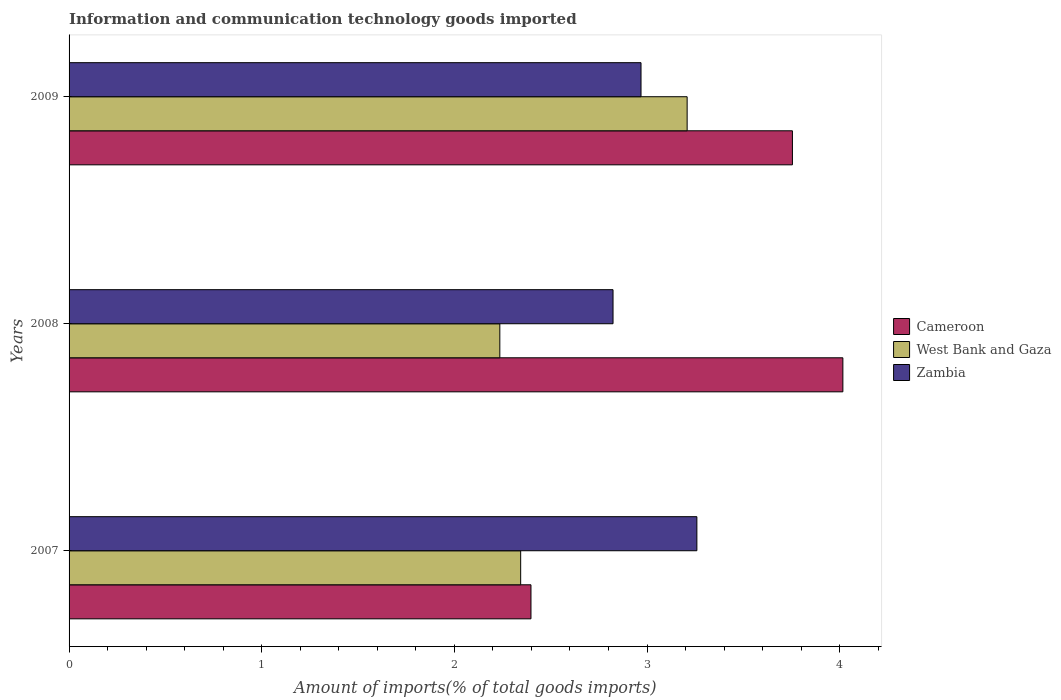What is the label of the 1st group of bars from the top?
Offer a terse response. 2009. What is the amount of goods imported in Cameroon in 2008?
Offer a very short reply. 4.02. Across all years, what is the maximum amount of goods imported in Zambia?
Provide a succinct answer. 3.26. Across all years, what is the minimum amount of goods imported in Cameroon?
Provide a succinct answer. 2.4. In which year was the amount of goods imported in West Bank and Gaza maximum?
Ensure brevity in your answer.  2009. In which year was the amount of goods imported in Cameroon minimum?
Offer a terse response. 2007. What is the total amount of goods imported in Cameroon in the graph?
Make the answer very short. 10.17. What is the difference between the amount of goods imported in Cameroon in 2007 and that in 2009?
Your answer should be very brief. -1.36. What is the difference between the amount of goods imported in Zambia in 2009 and the amount of goods imported in West Bank and Gaza in 2007?
Provide a short and direct response. 0.62. What is the average amount of goods imported in Cameroon per year?
Give a very brief answer. 3.39. In the year 2007, what is the difference between the amount of goods imported in Zambia and amount of goods imported in Cameroon?
Ensure brevity in your answer.  0.86. In how many years, is the amount of goods imported in West Bank and Gaza greater than 0.2 %?
Keep it short and to the point. 3. What is the ratio of the amount of goods imported in Zambia in 2007 to that in 2008?
Ensure brevity in your answer.  1.15. What is the difference between the highest and the second highest amount of goods imported in West Bank and Gaza?
Your response must be concise. 0.86. What is the difference between the highest and the lowest amount of goods imported in Zambia?
Offer a terse response. 0.44. Is the sum of the amount of goods imported in Cameroon in 2007 and 2009 greater than the maximum amount of goods imported in West Bank and Gaza across all years?
Keep it short and to the point. Yes. What does the 3rd bar from the top in 2009 represents?
Ensure brevity in your answer.  Cameroon. What does the 2nd bar from the bottom in 2007 represents?
Your answer should be compact. West Bank and Gaza. Is it the case that in every year, the sum of the amount of goods imported in Cameroon and amount of goods imported in West Bank and Gaza is greater than the amount of goods imported in Zambia?
Keep it short and to the point. Yes. How many years are there in the graph?
Provide a short and direct response. 3. How many legend labels are there?
Make the answer very short. 3. How are the legend labels stacked?
Offer a very short reply. Vertical. What is the title of the graph?
Offer a terse response. Information and communication technology goods imported. What is the label or title of the X-axis?
Keep it short and to the point. Amount of imports(% of total goods imports). What is the Amount of imports(% of total goods imports) of Cameroon in 2007?
Your answer should be compact. 2.4. What is the Amount of imports(% of total goods imports) of West Bank and Gaza in 2007?
Provide a succinct answer. 2.34. What is the Amount of imports(% of total goods imports) in Zambia in 2007?
Make the answer very short. 3.26. What is the Amount of imports(% of total goods imports) of Cameroon in 2008?
Give a very brief answer. 4.02. What is the Amount of imports(% of total goods imports) in West Bank and Gaza in 2008?
Make the answer very short. 2.24. What is the Amount of imports(% of total goods imports) of Zambia in 2008?
Your answer should be compact. 2.82. What is the Amount of imports(% of total goods imports) of Cameroon in 2009?
Your answer should be very brief. 3.75. What is the Amount of imports(% of total goods imports) of West Bank and Gaza in 2009?
Your answer should be very brief. 3.21. What is the Amount of imports(% of total goods imports) in Zambia in 2009?
Your answer should be compact. 2.97. Across all years, what is the maximum Amount of imports(% of total goods imports) of Cameroon?
Provide a succinct answer. 4.02. Across all years, what is the maximum Amount of imports(% of total goods imports) of West Bank and Gaza?
Provide a short and direct response. 3.21. Across all years, what is the maximum Amount of imports(% of total goods imports) of Zambia?
Your response must be concise. 3.26. Across all years, what is the minimum Amount of imports(% of total goods imports) in Cameroon?
Offer a terse response. 2.4. Across all years, what is the minimum Amount of imports(% of total goods imports) in West Bank and Gaza?
Keep it short and to the point. 2.24. Across all years, what is the minimum Amount of imports(% of total goods imports) in Zambia?
Your answer should be very brief. 2.82. What is the total Amount of imports(% of total goods imports) of Cameroon in the graph?
Ensure brevity in your answer.  10.17. What is the total Amount of imports(% of total goods imports) of West Bank and Gaza in the graph?
Give a very brief answer. 7.79. What is the total Amount of imports(% of total goods imports) in Zambia in the graph?
Your response must be concise. 9.05. What is the difference between the Amount of imports(% of total goods imports) of Cameroon in 2007 and that in 2008?
Your answer should be compact. -1.62. What is the difference between the Amount of imports(% of total goods imports) in West Bank and Gaza in 2007 and that in 2008?
Keep it short and to the point. 0.11. What is the difference between the Amount of imports(% of total goods imports) of Zambia in 2007 and that in 2008?
Offer a terse response. 0.44. What is the difference between the Amount of imports(% of total goods imports) of Cameroon in 2007 and that in 2009?
Provide a short and direct response. -1.36. What is the difference between the Amount of imports(% of total goods imports) of West Bank and Gaza in 2007 and that in 2009?
Keep it short and to the point. -0.86. What is the difference between the Amount of imports(% of total goods imports) of Zambia in 2007 and that in 2009?
Your answer should be compact. 0.29. What is the difference between the Amount of imports(% of total goods imports) in Cameroon in 2008 and that in 2009?
Your answer should be compact. 0.26. What is the difference between the Amount of imports(% of total goods imports) of West Bank and Gaza in 2008 and that in 2009?
Offer a very short reply. -0.97. What is the difference between the Amount of imports(% of total goods imports) in Zambia in 2008 and that in 2009?
Your answer should be compact. -0.15. What is the difference between the Amount of imports(% of total goods imports) of Cameroon in 2007 and the Amount of imports(% of total goods imports) of West Bank and Gaza in 2008?
Offer a very short reply. 0.16. What is the difference between the Amount of imports(% of total goods imports) in Cameroon in 2007 and the Amount of imports(% of total goods imports) in Zambia in 2008?
Give a very brief answer. -0.43. What is the difference between the Amount of imports(% of total goods imports) in West Bank and Gaza in 2007 and the Amount of imports(% of total goods imports) in Zambia in 2008?
Ensure brevity in your answer.  -0.48. What is the difference between the Amount of imports(% of total goods imports) of Cameroon in 2007 and the Amount of imports(% of total goods imports) of West Bank and Gaza in 2009?
Make the answer very short. -0.81. What is the difference between the Amount of imports(% of total goods imports) of Cameroon in 2007 and the Amount of imports(% of total goods imports) of Zambia in 2009?
Provide a succinct answer. -0.57. What is the difference between the Amount of imports(% of total goods imports) in West Bank and Gaza in 2007 and the Amount of imports(% of total goods imports) in Zambia in 2009?
Your response must be concise. -0.62. What is the difference between the Amount of imports(% of total goods imports) in Cameroon in 2008 and the Amount of imports(% of total goods imports) in West Bank and Gaza in 2009?
Keep it short and to the point. 0.81. What is the difference between the Amount of imports(% of total goods imports) in Cameroon in 2008 and the Amount of imports(% of total goods imports) in Zambia in 2009?
Provide a succinct answer. 1.05. What is the difference between the Amount of imports(% of total goods imports) of West Bank and Gaza in 2008 and the Amount of imports(% of total goods imports) of Zambia in 2009?
Offer a terse response. -0.73. What is the average Amount of imports(% of total goods imports) in Cameroon per year?
Ensure brevity in your answer.  3.39. What is the average Amount of imports(% of total goods imports) in West Bank and Gaza per year?
Give a very brief answer. 2.6. What is the average Amount of imports(% of total goods imports) in Zambia per year?
Offer a very short reply. 3.02. In the year 2007, what is the difference between the Amount of imports(% of total goods imports) of Cameroon and Amount of imports(% of total goods imports) of West Bank and Gaza?
Give a very brief answer. 0.05. In the year 2007, what is the difference between the Amount of imports(% of total goods imports) in Cameroon and Amount of imports(% of total goods imports) in Zambia?
Your answer should be compact. -0.86. In the year 2007, what is the difference between the Amount of imports(% of total goods imports) in West Bank and Gaza and Amount of imports(% of total goods imports) in Zambia?
Offer a terse response. -0.91. In the year 2008, what is the difference between the Amount of imports(% of total goods imports) of Cameroon and Amount of imports(% of total goods imports) of West Bank and Gaza?
Offer a very short reply. 1.78. In the year 2008, what is the difference between the Amount of imports(% of total goods imports) of Cameroon and Amount of imports(% of total goods imports) of Zambia?
Keep it short and to the point. 1.19. In the year 2008, what is the difference between the Amount of imports(% of total goods imports) of West Bank and Gaza and Amount of imports(% of total goods imports) of Zambia?
Your answer should be very brief. -0.59. In the year 2009, what is the difference between the Amount of imports(% of total goods imports) of Cameroon and Amount of imports(% of total goods imports) of West Bank and Gaza?
Your answer should be compact. 0.55. In the year 2009, what is the difference between the Amount of imports(% of total goods imports) of Cameroon and Amount of imports(% of total goods imports) of Zambia?
Your answer should be compact. 0.79. In the year 2009, what is the difference between the Amount of imports(% of total goods imports) in West Bank and Gaza and Amount of imports(% of total goods imports) in Zambia?
Make the answer very short. 0.24. What is the ratio of the Amount of imports(% of total goods imports) in Cameroon in 2007 to that in 2008?
Provide a succinct answer. 0.6. What is the ratio of the Amount of imports(% of total goods imports) in West Bank and Gaza in 2007 to that in 2008?
Make the answer very short. 1.05. What is the ratio of the Amount of imports(% of total goods imports) in Zambia in 2007 to that in 2008?
Your answer should be very brief. 1.15. What is the ratio of the Amount of imports(% of total goods imports) in Cameroon in 2007 to that in 2009?
Keep it short and to the point. 0.64. What is the ratio of the Amount of imports(% of total goods imports) of West Bank and Gaza in 2007 to that in 2009?
Provide a short and direct response. 0.73. What is the ratio of the Amount of imports(% of total goods imports) in Zambia in 2007 to that in 2009?
Ensure brevity in your answer.  1.1. What is the ratio of the Amount of imports(% of total goods imports) of Cameroon in 2008 to that in 2009?
Your answer should be very brief. 1.07. What is the ratio of the Amount of imports(% of total goods imports) in West Bank and Gaza in 2008 to that in 2009?
Offer a very short reply. 0.7. What is the ratio of the Amount of imports(% of total goods imports) of Zambia in 2008 to that in 2009?
Ensure brevity in your answer.  0.95. What is the difference between the highest and the second highest Amount of imports(% of total goods imports) in Cameroon?
Provide a short and direct response. 0.26. What is the difference between the highest and the second highest Amount of imports(% of total goods imports) in West Bank and Gaza?
Offer a terse response. 0.86. What is the difference between the highest and the second highest Amount of imports(% of total goods imports) of Zambia?
Provide a short and direct response. 0.29. What is the difference between the highest and the lowest Amount of imports(% of total goods imports) in Cameroon?
Your response must be concise. 1.62. What is the difference between the highest and the lowest Amount of imports(% of total goods imports) in West Bank and Gaza?
Provide a short and direct response. 0.97. What is the difference between the highest and the lowest Amount of imports(% of total goods imports) of Zambia?
Offer a terse response. 0.44. 